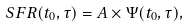Convert formula to latex. <formula><loc_0><loc_0><loc_500><loc_500>S F R ( t _ { 0 } , \tau ) = A \times \Psi ( t _ { 0 } , \tau ) ,</formula> 